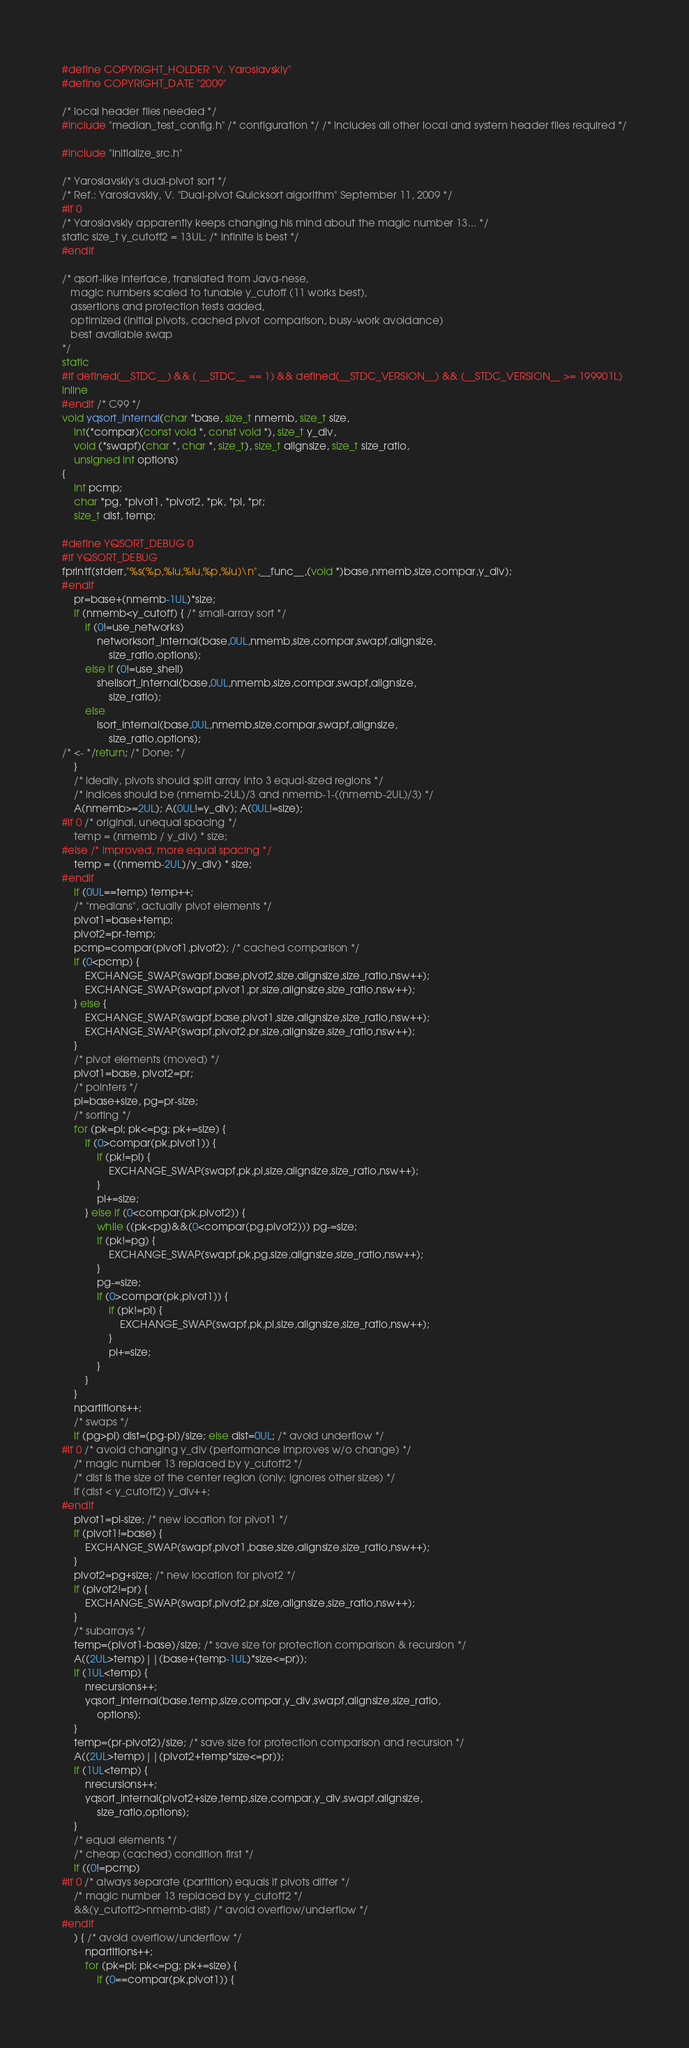<code> <loc_0><loc_0><loc_500><loc_500><_C_>#define COPYRIGHT_HOLDER "V. Yaroslavskiy"
#define COPYRIGHT_DATE "2009"

/* local header files needed */
#include "median_test_config.h" /* configuration */ /* includes all other local and system header files required */

#include "initialize_src.h"

/* Yaroslavskiy's dual-pivot sort */
/* Ref.: Yaroslavskiy, V. "Dual-pivot Quicksort algorithm" September 11, 2009 */
#if 0
/* Yaroslavskiy apparently keeps changing his mind about the magic number 13... */
static size_t y_cutoff2 = 13UL; /* infinite is best */
#endif

/* qsort-like interface, translated from Java-nese,
   magic numbers scaled to tunable y_cutoff (11 works best),
   assertions and protection tests added,
   optimized (initial pivots, cached pivot comparison, busy-work avoidance)
   best available swap
*/
static
#if defined(__STDC__) && ( __STDC__ == 1) && defined(__STDC_VERSION__) && (__STDC_VERSION__ >= 199901L)
inline
#endif /* C99 */
void yqsort_internal(char *base, size_t nmemb, size_t size,
    int(*compar)(const void *, const void *), size_t y_div,
    void (*swapf)(char *, char *, size_t), size_t alignsize, size_t size_ratio,
    unsigned int options)
{
    int pcmp;
    char *pg, *pivot1, *pivot2, *pk, *pl, *pr;
    size_t dist, temp;

#define YQSORT_DEBUG 0
#if YQSORT_DEBUG
fprintf(stderr,"%s(%p,%lu,%lu,%p,%lu)\n",__func__,(void *)base,nmemb,size,compar,y_div);
#endif
    pr=base+(nmemb-1UL)*size;
    if (nmemb<y_cutoff) { /* small-array sort */
        if (0!=use_networks)
            networksort_internal(base,0UL,nmemb,size,compar,swapf,alignsize,
                size_ratio,options);
        else if (0!=use_shell)
            shellsort_internal(base,0UL,nmemb,size,compar,swapf,alignsize,
                size_ratio);
        else
            isort_internal(base,0UL,nmemb,size,compar,swapf,alignsize,
                size_ratio,options);
/* <- */return; /* Done; */
    }
    /* ideally, pivots should split array into 3 equal-sized regions */
    /* indices should be (nmemb-2UL)/3 and nmemb-1-((nmemb-2UL)/3) */
    A(nmemb>=2UL); A(0UL!=y_div); A(0UL!=size);
#if 0 /* original, unequal spacing */
    temp = (nmemb / y_div) * size;
#else /* improved, more equal spacing */
    temp = ((nmemb-2UL)/y_div) * size;
#endif
    if (0UL==temp) temp++;
    /* "medians", actually pivot elements */
    pivot1=base+temp;
    pivot2=pr-temp;
    pcmp=compar(pivot1,pivot2); /* cached comparison */
    if (0<pcmp) {
        EXCHANGE_SWAP(swapf,base,pivot2,size,alignsize,size_ratio,nsw++);
        EXCHANGE_SWAP(swapf,pivot1,pr,size,alignsize,size_ratio,nsw++);
    } else {
        EXCHANGE_SWAP(swapf,base,pivot1,size,alignsize,size_ratio,nsw++);
        EXCHANGE_SWAP(swapf,pivot2,pr,size,alignsize,size_ratio,nsw++);
    }
    /* pivot elements (moved) */
    pivot1=base, pivot2=pr;
    /* pointers */
    pl=base+size, pg=pr-size;
    /* sorting */
    for (pk=pl; pk<=pg; pk+=size) {
        if (0>compar(pk,pivot1)) {
            if (pk!=pl) {
                EXCHANGE_SWAP(swapf,pk,pl,size,alignsize,size_ratio,nsw++);
            }
            pl+=size;
        } else if (0<compar(pk,pivot2)) {
            while ((pk<pg)&&(0<compar(pg,pivot2))) pg-=size;
            if (pk!=pg) {
                EXCHANGE_SWAP(swapf,pk,pg,size,alignsize,size_ratio,nsw++);
            }
            pg-=size;
            if (0>compar(pk,pivot1)) {
                if (pk!=pl) {
                    EXCHANGE_SWAP(swapf,pk,pl,size,alignsize,size_ratio,nsw++);
                }
                pl+=size;
            }
        }
    }
    npartitions++;
    /* swaps */
    if (pg>pl) dist=(pg-pl)/size; else dist=0UL; /* avoid underflow */
#if 0 /* avoid changing y_div (performance improves w/o change) */
    /* magic number 13 replaced by y_cutoff2 */
    /* dist is the size of the center region (only; ignores other sizes) */
    if (dist < y_cutoff2) y_div++;
#endif
    pivot1=pl-size; /* new location for pivot1 */
    if (pivot1!=base) {
        EXCHANGE_SWAP(swapf,pivot1,base,size,alignsize,size_ratio,nsw++);
    }
    pivot2=pg+size; /* new location for pivot2 */
    if (pivot2!=pr) {
        EXCHANGE_SWAP(swapf,pivot2,pr,size,alignsize,size_ratio,nsw++);
    }
    /* subarrays */
    temp=(pivot1-base)/size; /* save size for protection comparison & recursion */
    A((2UL>temp)||(base+(temp-1UL)*size<=pr));
    if (1UL<temp) {
        nrecursions++;
        yqsort_internal(base,temp,size,compar,y_div,swapf,alignsize,size_ratio,
            options);
    }
    temp=(pr-pivot2)/size; /* save size for protection comparison and recursion */
    A((2UL>temp)||(pivot2+temp*size<=pr));
    if (1UL<temp) {
        nrecursions++;
        yqsort_internal(pivot2+size,temp,size,compar,y_div,swapf,alignsize,
            size_ratio,options);
    }
    /* equal elements */
    /* cheap (cached) condition first */
    if ((0!=pcmp)
#if 0 /* always separate (partition) equals if pivots differ */
    /* magic number 13 replaced by y_cutoff2 */
    &&(y_cutoff2>nmemb-dist) /* avoid overflow/underflow */
#endif
    ) { /* avoid overflow/underflow */
        npartitions++;
        for (pk=pl; pk<=pg; pk+=size) {
            if (0==compar(pk,pivot1)) {</code> 